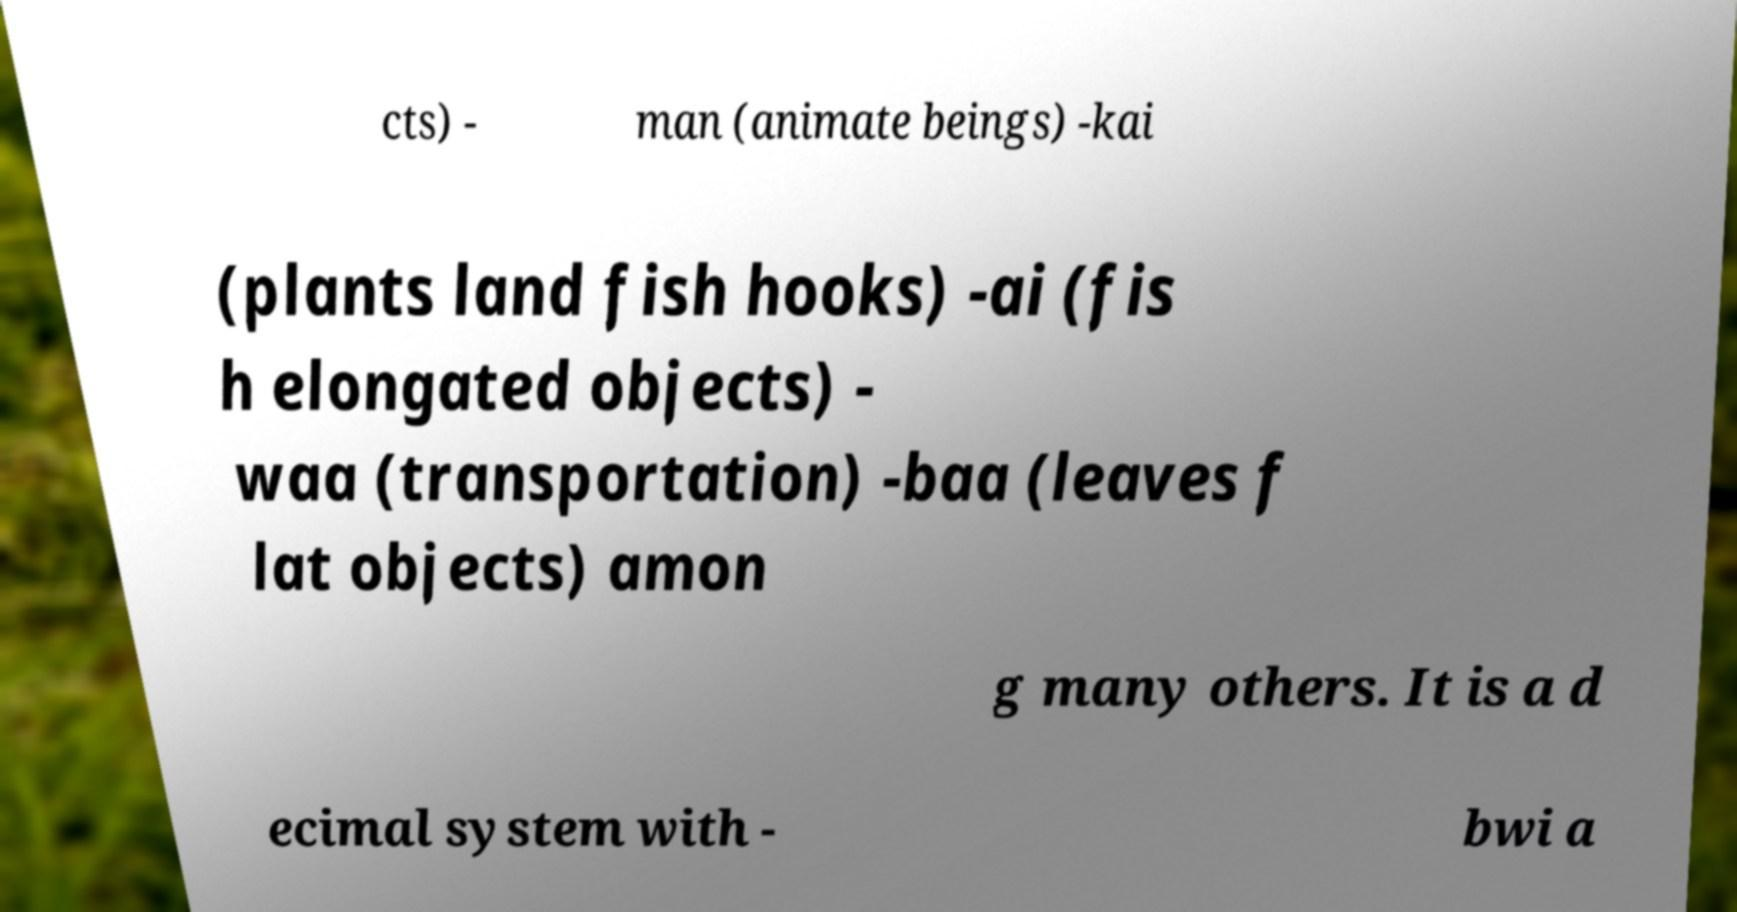Please identify and transcribe the text found in this image. cts) - man (animate beings) -kai (plants land fish hooks) -ai (fis h elongated objects) - waa (transportation) -baa (leaves f lat objects) amon g many others. It is a d ecimal system with - bwi a 